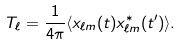<formula> <loc_0><loc_0><loc_500><loc_500>T _ { \ell } = \frac { 1 } { 4 \pi } \langle x _ { \ell m } ( t ) x ^ { * } _ { \ell m } ( t ^ { \prime } ) \rangle .</formula> 